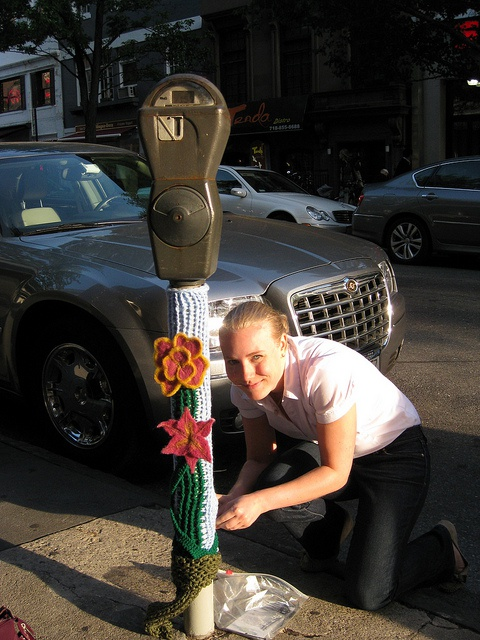Describe the objects in this image and their specific colors. I can see car in black, blue, gray, and darkblue tones, people in black, white, tan, and maroon tones, parking meter in black, gray, maroon, and white tones, car in black, darkblue, and gray tones, and car in black and gray tones in this image. 